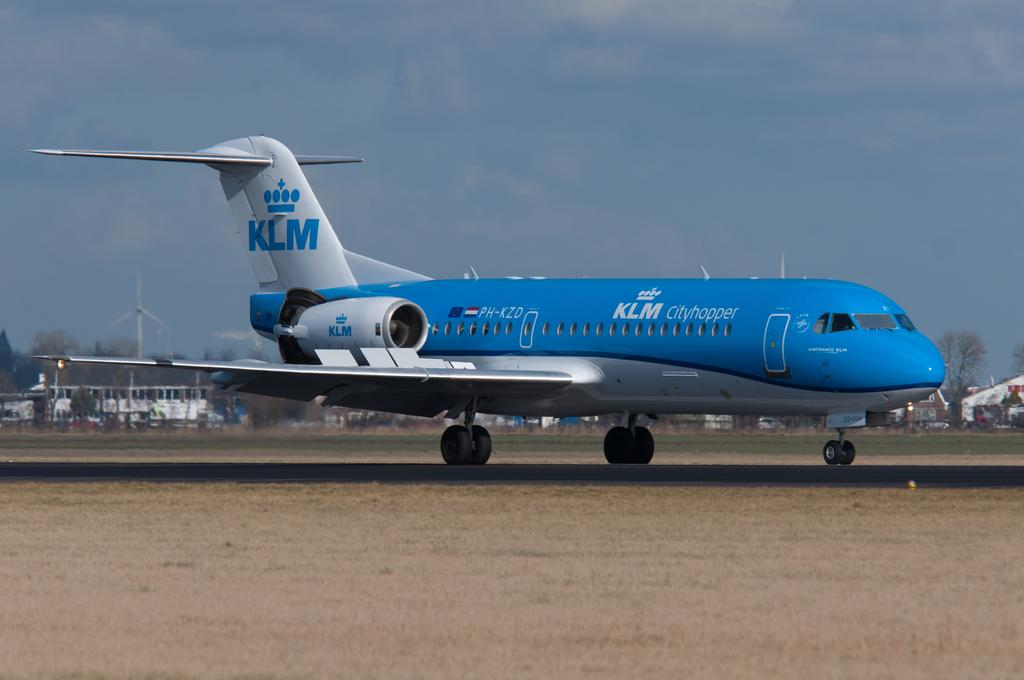<image>
Offer a succinct explanation of the picture presented. The KLM aircraft is mostly blue but with a white tail with blue letters saying KLM. 